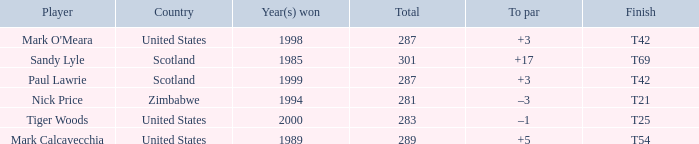What is Tiger Woods' to par? –1. 